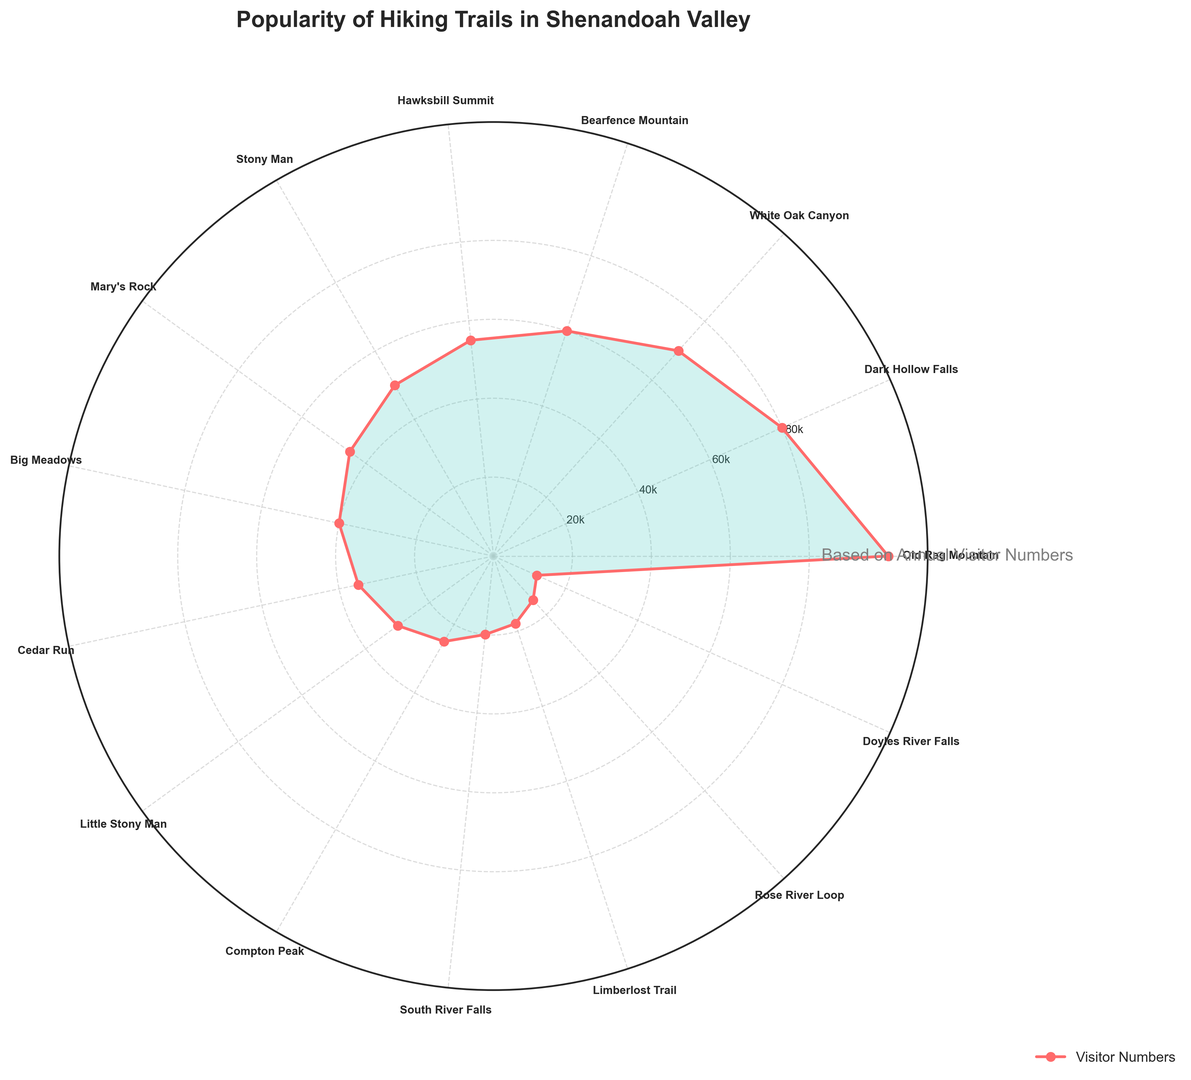What's the most popular hiking trail? The most popular hiking trail can be identified by the highest value on the rose chart. The trail with the highest number of annual visitors is Old Rag Mountain which peaks at 100,000 visitors.
Answer: Old Rag Mountain Which trail has fewer visitors: Stony Man or Mary's Rock? To compare the two trails, look at their respective positions on the chart and compare the height of their values. Stony Man has 50,000 visitors while Mary's Rock has 45,000 visitors, meaning Mary's Rock has fewer visitors.
Answer: Mary's Rock What is the visitor difference between Dark Hollow Falls and Cedar Run? To find the difference, identify the visitor numbers for both trails: Dark Hollow Falls has 80,000 visitors and Cedar Run has 35,000 visitors. Calculate the difference: 80,000 - 35,000.
Answer: 45,000 How many trails have more than 50,000 annual visitors? To determine this, count the number of trails that have values exceeding 50,000 in the chart. Trails above 50,000 include Old Rag Mountain, Dark Hollow Falls, White Oak Canyon, Bearfence Mountain, and Hawksbill Summit. This totals 5 trails.
Answer: 5 Which trails' visitor numbers are closest in value? Examine the visitor numbers and find the smallest difference between any two. Mary's Rock has 45,000 visitors and Big Meadows has 40,000 visitors, which have a difference of 5,000 visitors and are the closest in value.
Answer: Mary's Rock and Big Meadows What's the combined number of visitors for the three least popular trails? Identify the three trails with the lowest visitors: Limberlost Trail (18,000), Rose River Loop (15,000), and Doyles River Falls (12,000). Sum these values: 18,000 + 15,000 + 12,000.
Answer: 45,000 Is the number of visitors for Old Rag Mountain more than twice that of Hawksbill Summit? Old Rag Mountain has 100,000 visitors and Hawksbill Summit has 55,000 visitors. To check if it is more than twice: 55,000 * 2 = 110,000. Since 100,000 is not more than 110,000, the answer is no.
Answer: No What is the average number of visitors for trails with less than 30,000 annual visitors? Identify the trails with less than 30,000 visitors: Little Stony Man (30,000), Compton Peak (25,000), South River Falls (20,000), Limberlost Trail (18,000), Rose River Loop (15,000), Doyles River Falls (12,000). Sum these values: 30,000 + 25,000 + 20,000 + 18,000 + 15,000 + 12,000 = 120,000. Divide by the number of trails: 120,000 / 6.
Answer: 20,000 